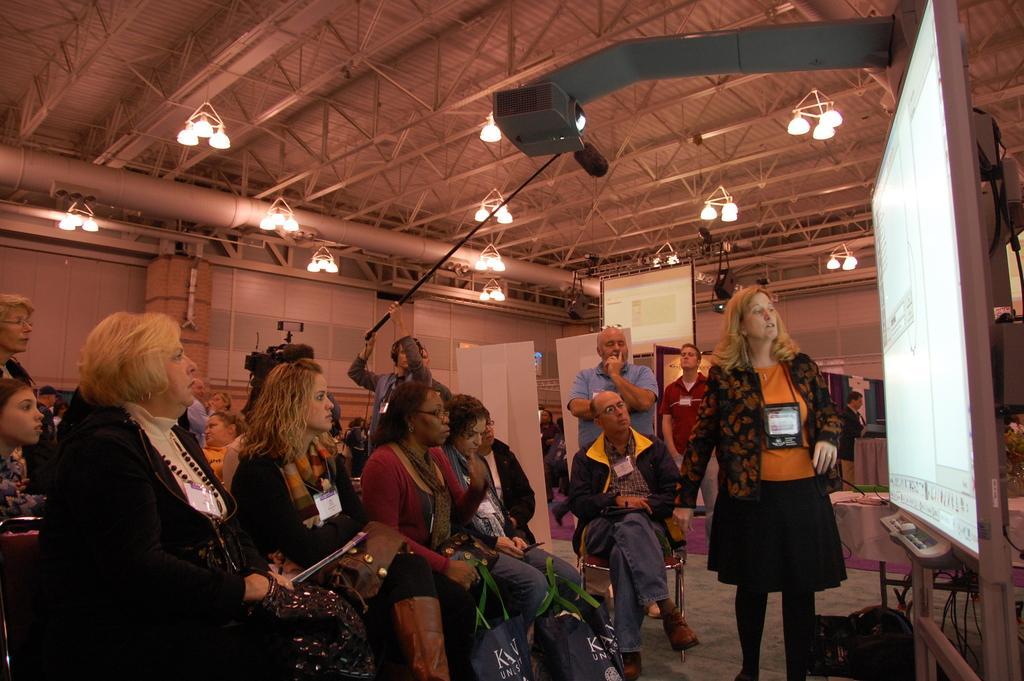Describe this image in one or two sentences. In this image we can see some group of lady persons sitting on chairs watching towards projector screen on which something displaying there is person standing near the projector screen explaining something and in the background of the image there is a man who is holding a stick which has camera, there are some other projector screens, lights and roof. 